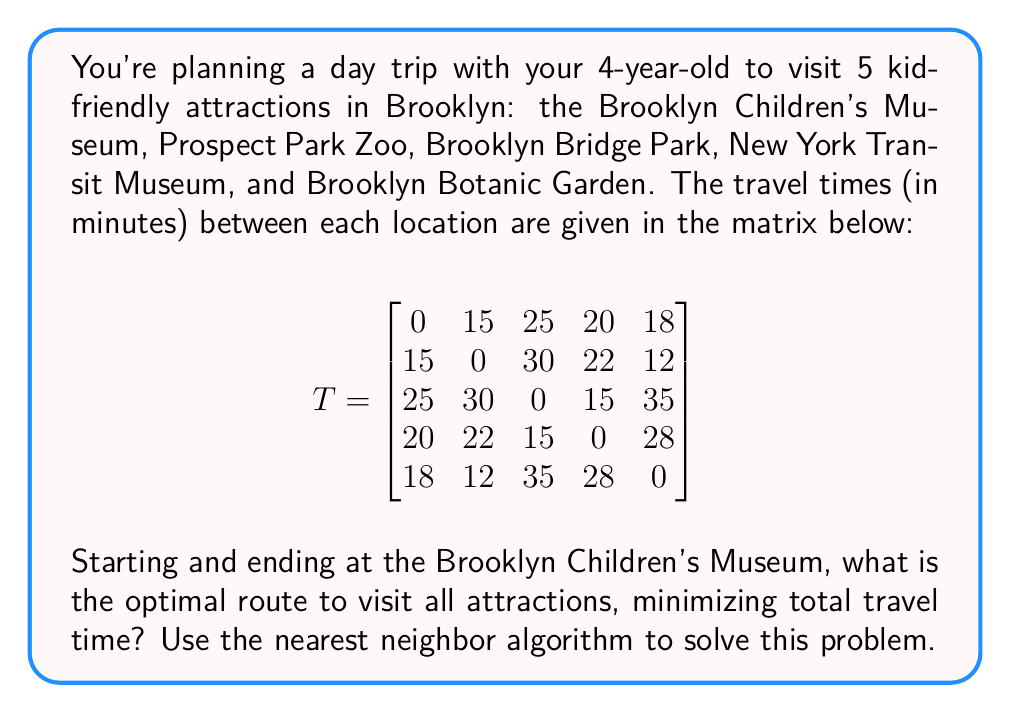What is the answer to this math problem? Let's solve this problem using the nearest neighbor algorithm:

1) Start at the Brooklyn Children's Museum (1).

2) Find the nearest unvisited attraction:
   - To Prospect Park Zoo (2): 15 minutes
   - To Brooklyn Bridge Park (3): 25 minutes
   - To New York Transit Museum (4): 20 minutes
   - To Brooklyn Botanic Garden (5): 18 minutes
   The nearest is Prospect Park Zoo (2) with 15 minutes.

3) Move to Prospect Park Zoo (2) and repeat:
   - To Brooklyn Bridge Park (3): 30 minutes
   - To New York Transit Museum (4): 22 minutes
   - To Brooklyn Botanic Garden (5): 12 minutes
   The nearest is Brooklyn Botanic Garden (5) with 12 minutes.

4) Move to Brooklyn Botanic Garden (5) and repeat:
   - To Brooklyn Bridge Park (3): 35 minutes
   - To New York Transit Museum (4): 28 minutes
   The nearest is New York Transit Museum (4) with 28 minutes.

5) Move to New York Transit Museum (4) and visit the last remaining attraction:
   - To Brooklyn Bridge Park (3): 15 minutes

6) Finally, return to Brooklyn Children's Museum (1) from Brooklyn Bridge Park (3):
   - Travel time: 25 minutes

The total route is: 1 → 2 → 5 → 4 → 3 → 1
Total travel time: 15 + 12 + 28 + 15 + 25 = 95 minutes
Answer: 1 → 2 → 5 → 4 → 3 → 1; 95 minutes 